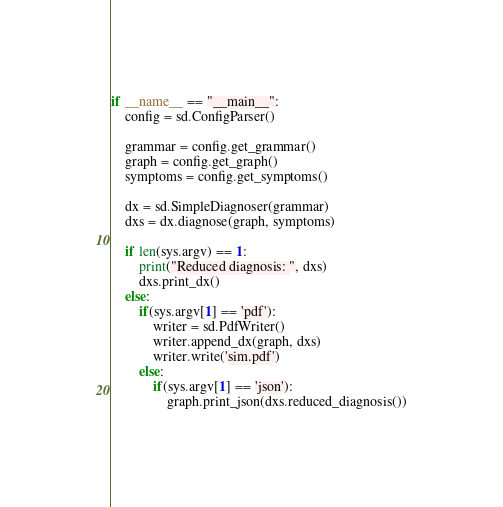<code> <loc_0><loc_0><loc_500><loc_500><_Python_>
if __name__ == "__main__":
    config = sd.ConfigParser()

    grammar = config.get_grammar()
    graph = config.get_graph()
    symptoms = config.get_symptoms()

    dx = sd.SimpleDiagnoser(grammar)
    dxs = dx.diagnose(graph, symptoms)

    if len(sys.argv) == 1:
        print("Reduced diagnosis: ", dxs)
        dxs.print_dx()
    else:
        if(sys.argv[1] == 'pdf'):
            writer = sd.PdfWriter()
            writer.append_dx(graph, dxs)
            writer.write('sim.pdf')
        else:
            if(sys.argv[1] == 'json'):
                graph.print_json(dxs.reduced_diagnosis())
</code> 